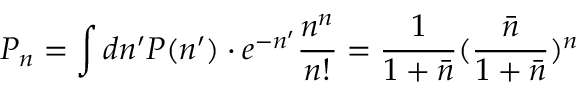Convert formula to latex. <formula><loc_0><loc_0><loc_500><loc_500>P _ { n } = \int d n ^ { \prime } P ( n ^ { \prime } ) \cdot e ^ { - n ^ { \prime } } \frac { n ^ { n } } { n ! } = \frac { 1 } { 1 + \bar { n } } ( \frac { \bar { n } } { 1 + \bar { n } } ) ^ { n }</formula> 